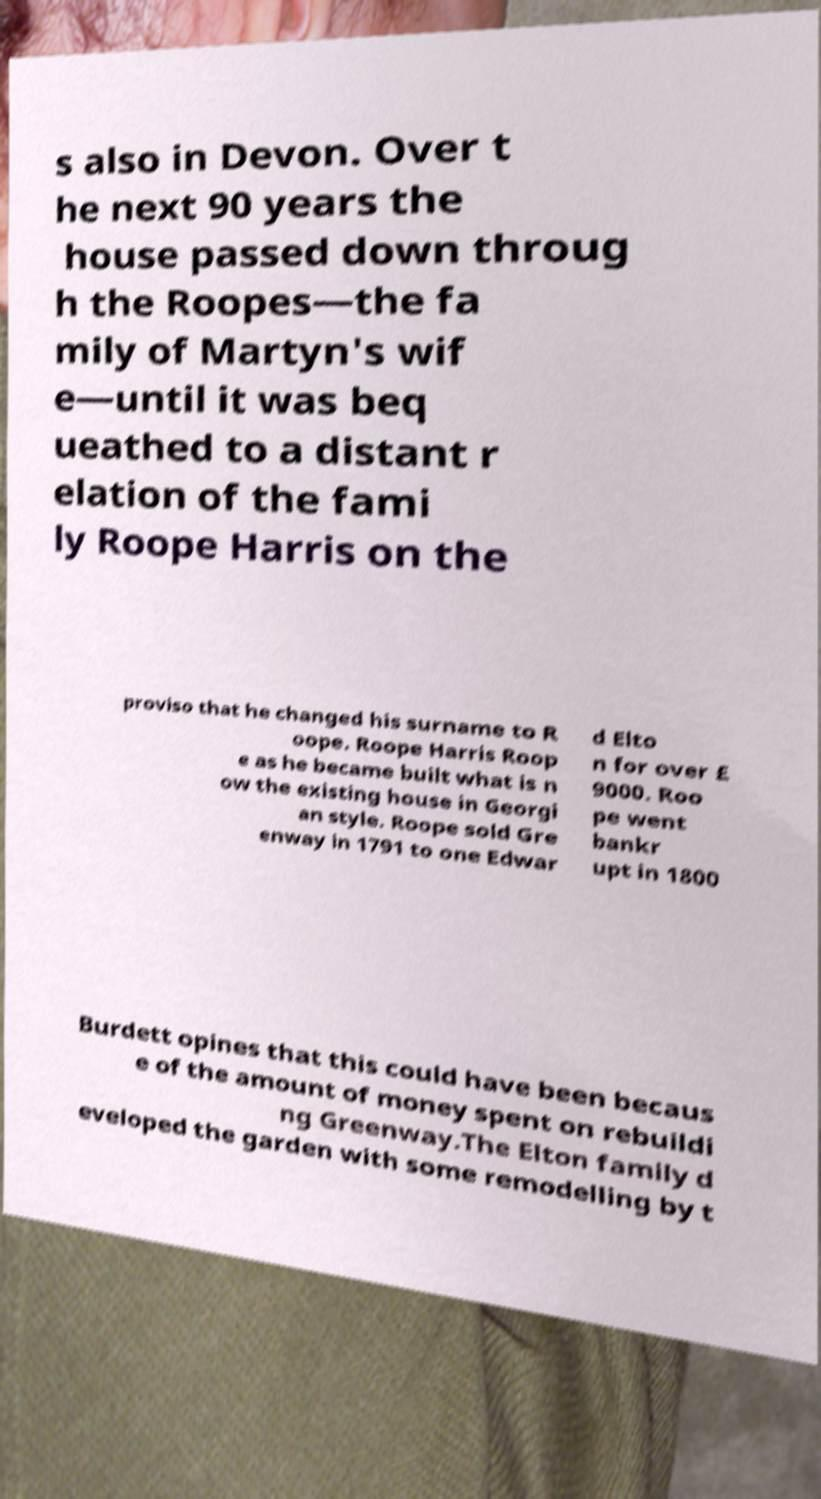Can you read and provide the text displayed in the image?This photo seems to have some interesting text. Can you extract and type it out for me? s also in Devon. Over t he next 90 years the house passed down throug h the Roopes—the fa mily of Martyn's wif e—until it was beq ueathed to a distant r elation of the fami ly Roope Harris on the proviso that he changed his surname to R oope. Roope Harris Roop e as he became built what is n ow the existing house in Georgi an style. Roope sold Gre enway in 1791 to one Edwar d Elto n for over £ 9000. Roo pe went bankr upt in 1800 Burdett opines that this could have been becaus e of the amount of money spent on rebuildi ng Greenway.The Elton family d eveloped the garden with some remodelling by t 